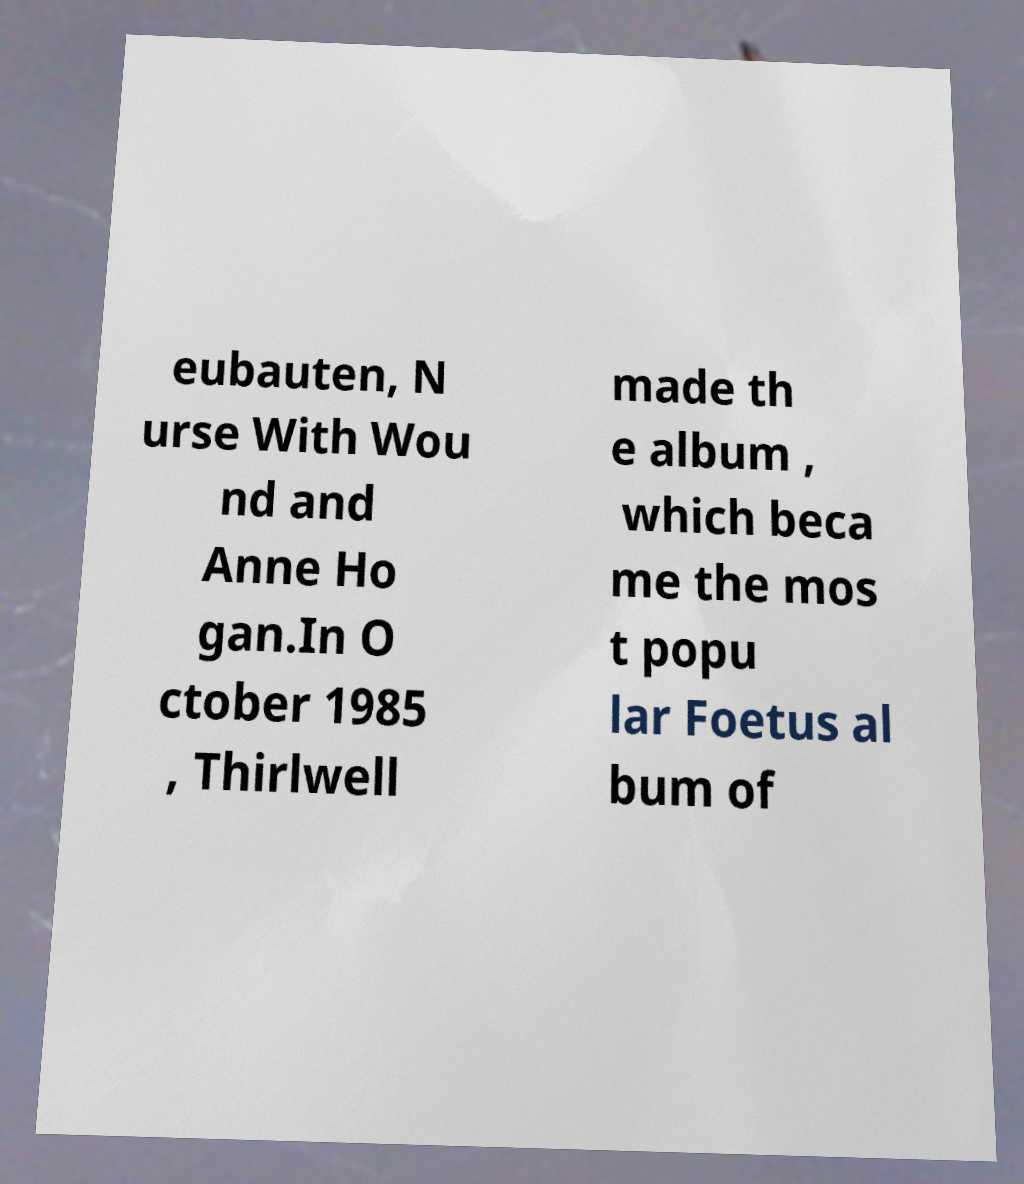Please read and relay the text visible in this image. What does it say? eubauten, N urse With Wou nd and Anne Ho gan.In O ctober 1985 , Thirlwell made th e album , which beca me the mos t popu lar Foetus al bum of 